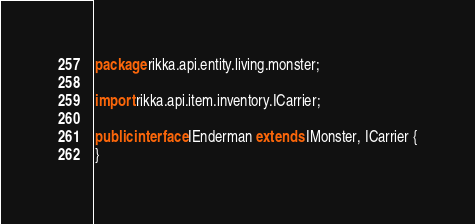Convert code to text. <code><loc_0><loc_0><loc_500><loc_500><_Java_>package rikka.api.entity.living.monster;

import rikka.api.item.inventory.ICarrier;

public interface IEnderman extends IMonster, ICarrier {
}
</code> 